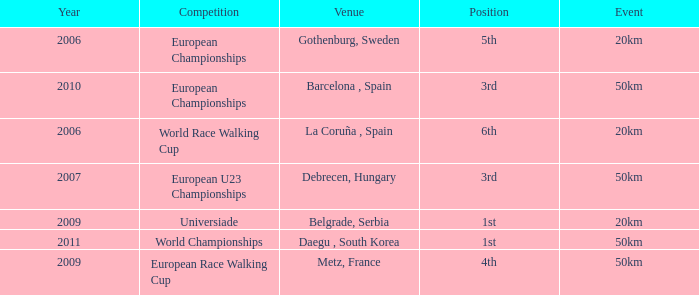Can you give me this table as a dict? {'header': ['Year', 'Competition', 'Venue', 'Position', 'Event'], 'rows': [['2006', 'European Championships', 'Gothenburg, Sweden', '5th', '20km'], ['2010', 'European Championships', 'Barcelona , Spain', '3rd', '50km'], ['2006', 'World Race Walking Cup', 'La Coruña , Spain', '6th', '20km'], ['2007', 'European U23 Championships', 'Debrecen, Hungary', '3rd', '50km'], ['2009', 'Universiade', 'Belgrade, Serbia', '1st', '20km'], ['2011', 'World Championships', 'Daegu , South Korea', '1st', '50km'], ['2009', 'European Race Walking Cup', 'Metz, France', '4th', '50km']]} What is the Position for the European U23 Championships? 3rd. 